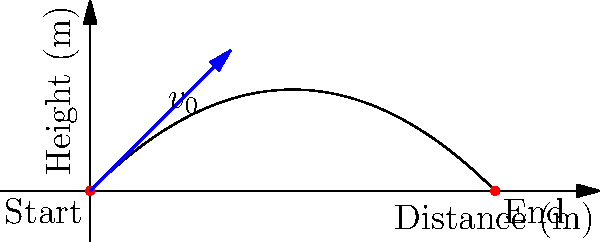As an elite athlete with experience in throwing, you're asked to calculate the maximum height reached by a ball thrown with an initial velocity of 20 m/s at a 45-degree angle. Assuming air resistance is negligible, what is the maximum height the ball reaches? (Use $g = 9.8$ m/s²) Let's approach this step-by-step:

1) The vertical component of the initial velocity is:
   $v_{0y} = v_0 \sin \theta = 20 \cdot \sin 45° = 20 \cdot \frac{\sqrt{2}}{2} \approx 14.14$ m/s

2) The time to reach maximum height is when the vertical velocity becomes zero:
   $t_{max} = \frac{v_{0y}}{g} = \frac{14.14}{9.8} \approx 1.44$ s

3) The maximum height can be calculated using the equation:
   $h_{max} = v_{0y}t - \frac{1}{2}gt^2$

4) Substituting the values:
   $h_{max} = 14.14 \cdot 1.44 - \frac{1}{2} \cdot 9.8 \cdot 1.44^2$

5) Calculating:
   $h_{max} = 20.36 - 10.18 = 10.18$ m

Therefore, the maximum height reached by the ball is approximately 10.18 meters.
Answer: 10.18 m 